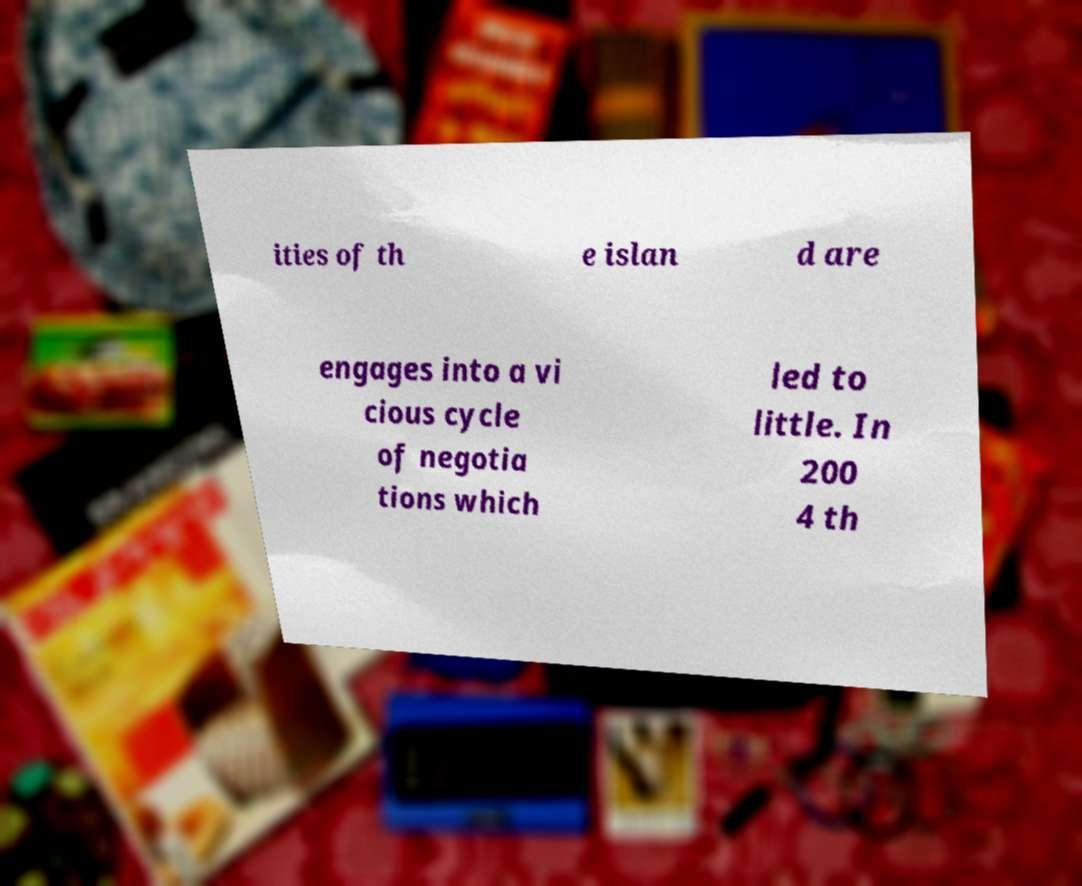There's text embedded in this image that I need extracted. Can you transcribe it verbatim? ities of th e islan d are engages into a vi cious cycle of negotia tions which led to little. In 200 4 th 